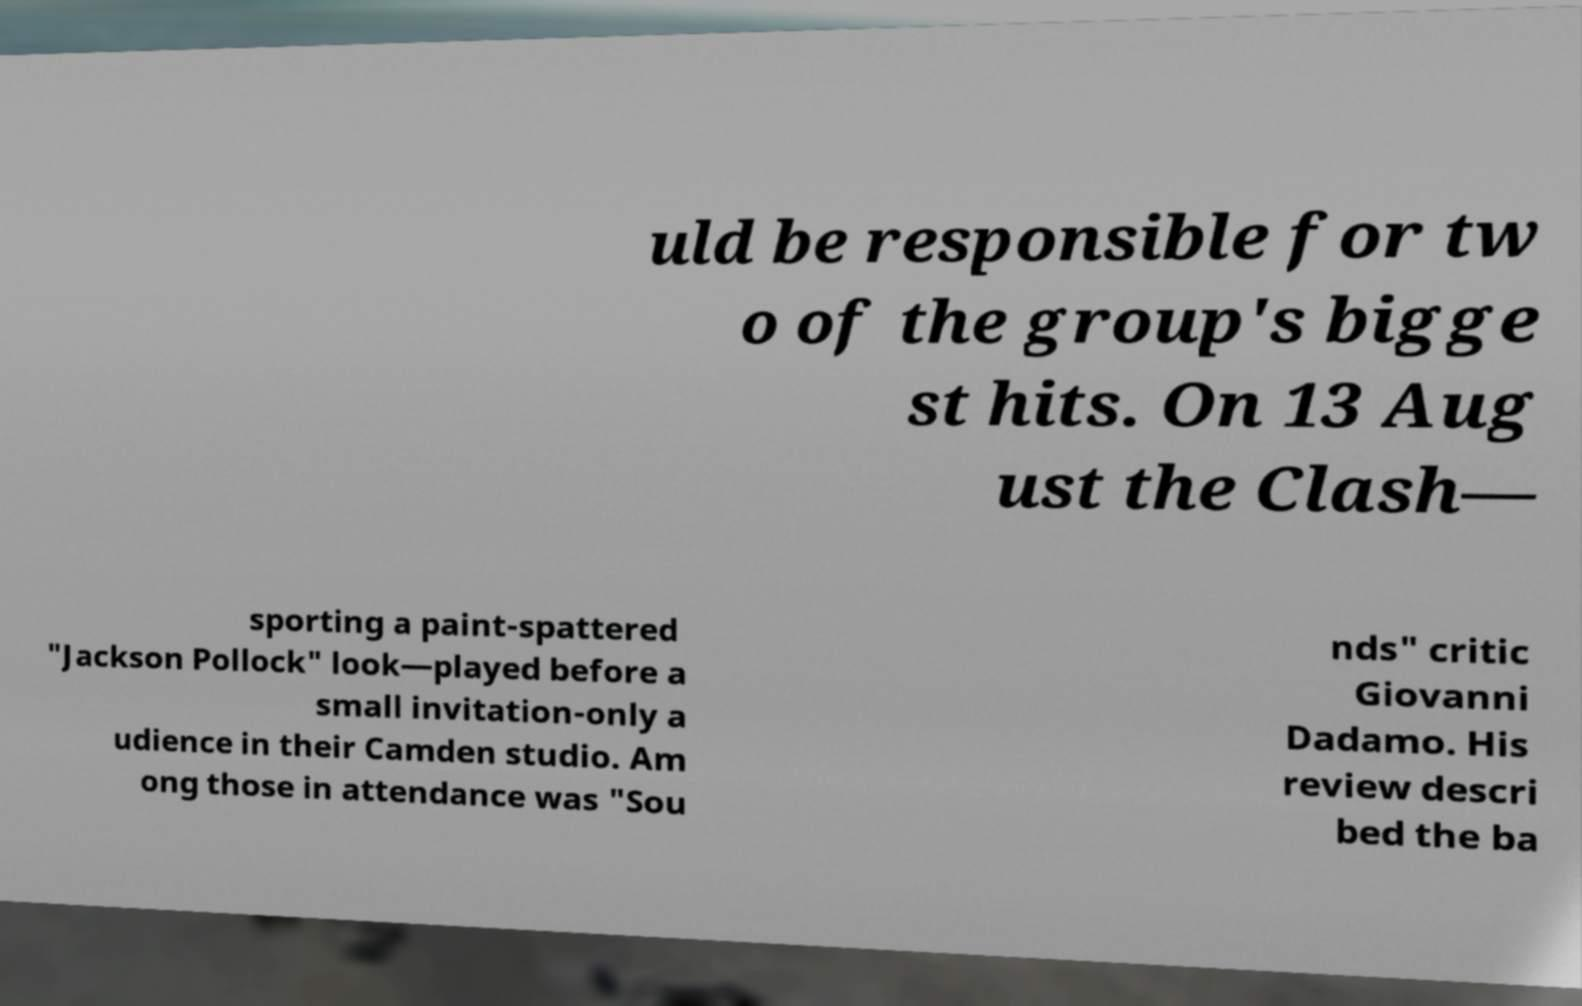I need the written content from this picture converted into text. Can you do that? uld be responsible for tw o of the group's bigge st hits. On 13 Aug ust the Clash— sporting a paint-spattered "Jackson Pollock" look—played before a small invitation-only a udience in their Camden studio. Am ong those in attendance was "Sou nds" critic Giovanni Dadamo. His review descri bed the ba 